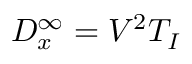Convert formula to latex. <formula><loc_0><loc_0><loc_500><loc_500>D _ { x } ^ { \infty } = V ^ { 2 } T _ { I }</formula> 